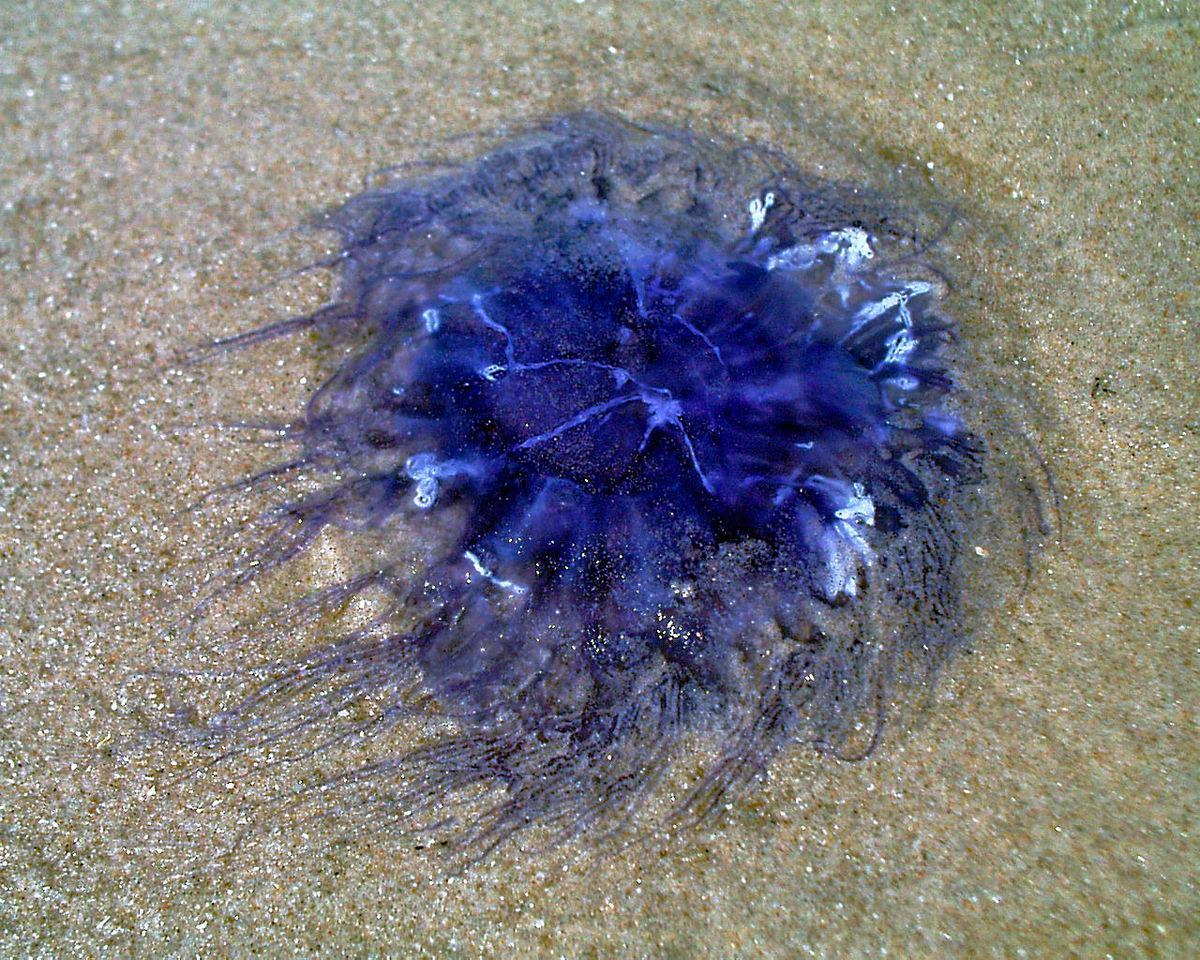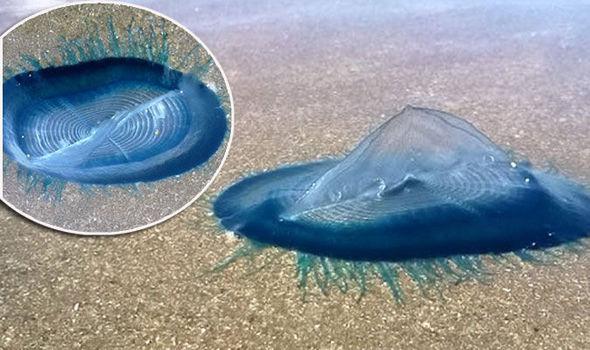The first image is the image on the left, the second image is the image on the right. Examine the images to the left and right. Is the description "Each picture only has one jellyfish." accurate? Answer yes or no. No. The first image is the image on the left, the second image is the image on the right. For the images displayed, is the sentence "Each image shows one prominent beached jellyfish that resembles an inflated bluish translucent balloon." factually correct? Answer yes or no. No. 